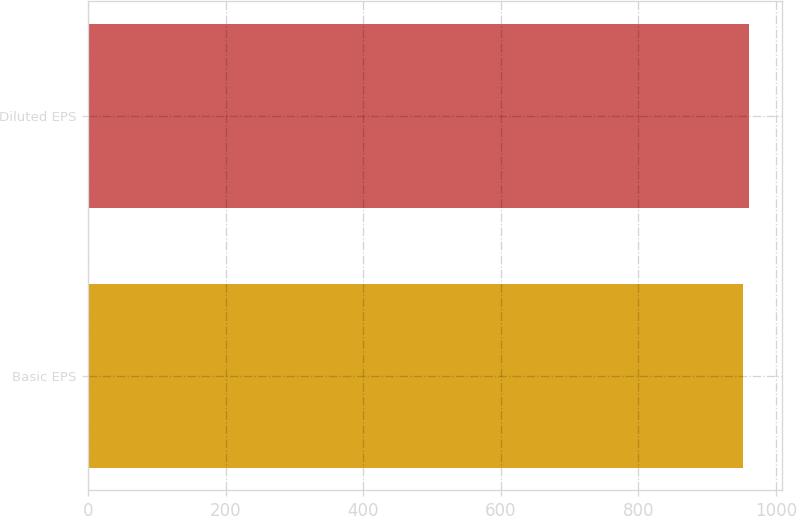Convert chart to OTSL. <chart><loc_0><loc_0><loc_500><loc_500><bar_chart><fcel>Basic EPS<fcel>Diluted EPS<nl><fcel>952.1<fcel>960.2<nl></chart> 